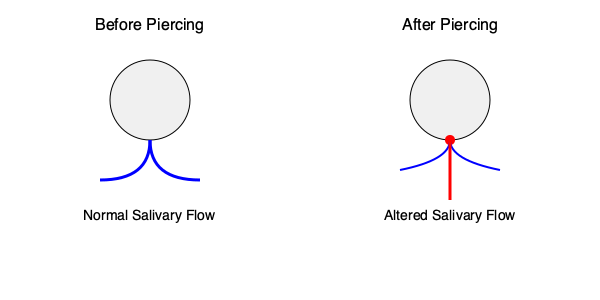Based on the illustration, how does an oral piercing typically affect salivary gland function, and what potential long-term consequence might this have on oral health? 1. Normal salivary flow (left image):
   - Saliva is evenly distributed from the salivary glands.
   - This ensures proper lubrication and protection of oral tissues.

2. Altered salivary flow after piercing (right image):
   - The piercing acts as an obstruction in the natural flow path.
   - Some saliva is diverted through the piercing site.
   - Overall distribution of saliva in the oral cavity is reduced.

3. Impact on salivary gland function:
   - The piercing can interfere with the normal secretion and distribution of saliva.
   - This may lead to a localized reduction in salivary flow to certain areas of the mouth.

4. Potential long-term consequences:
   - Reduced salivary flow can lead to dry mouth (xerostomia).
   - Xerostomia increases the risk of dental caries due to decreased remineralization and buffering capacity.
   - It may also contribute to increased risk of oral infections, as saliva plays a crucial role in maintaining oral microbiome balance.
   - Chronic irritation at the piercing site can lead to gingival recession and enamel wear on adjacent teeth.

5. Additional considerations:
   - The severity of the impact may vary depending on the location and size of the piercing.
   - Proper oral hygiene becomes even more critical for individuals with oral piercings to mitigate these risks.
Answer: Oral piercings can obstruct and alter salivary flow, potentially leading to localized dry mouth and increased risk of dental caries and oral infections. 